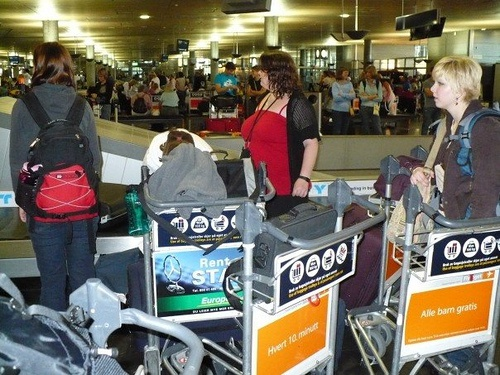Describe the objects in this image and their specific colors. I can see people in olive, black, navy, gray, and purple tones, people in olive, gray, darkgray, lightgray, and tan tones, people in olive, black, brown, maroon, and tan tones, backpack in olive, black, brown, and maroon tones, and people in olive, black, darkgreen, gray, and maroon tones in this image. 